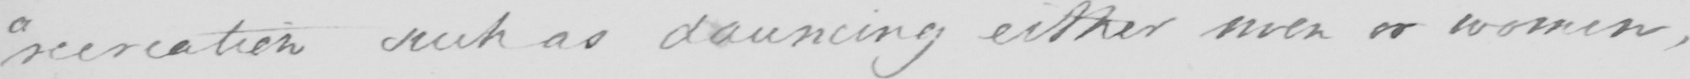Transcribe the text shown in this historical manuscript line. " recreation such as dauncing either men or women , 